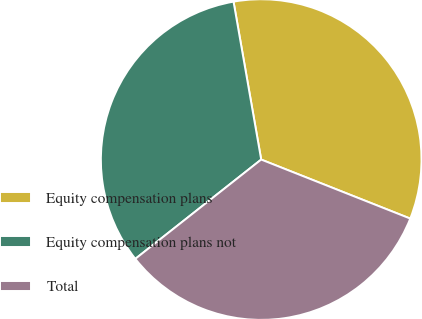Convert chart to OTSL. <chart><loc_0><loc_0><loc_500><loc_500><pie_chart><fcel>Equity compensation plans<fcel>Equity compensation plans not<fcel>Total<nl><fcel>33.76%<fcel>32.87%<fcel>33.37%<nl></chart> 